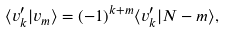Convert formula to latex. <formula><loc_0><loc_0><loc_500><loc_500>\langle v _ { k } ^ { \prime } | v _ { m } \rangle = ( - 1 ) ^ { k + m } \langle v _ { k } ^ { \prime } | N - m \rangle ,</formula> 